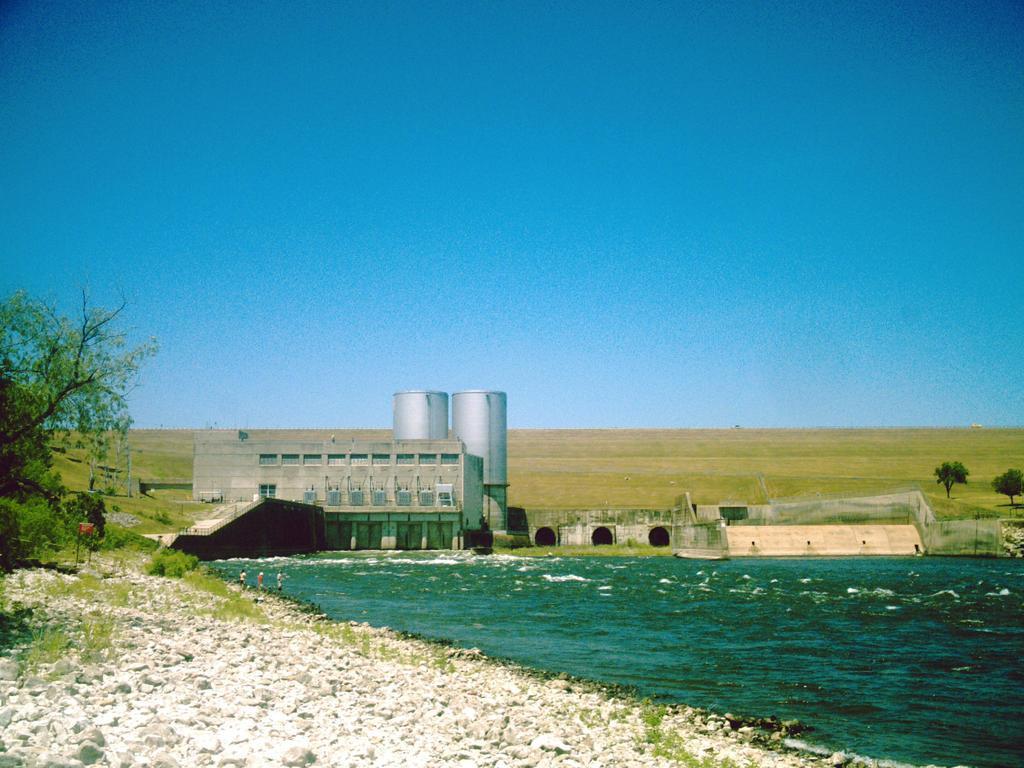Can you describe this image briefly? In this image I can see the sky and lake and some tankers visible in front of the lake and I can see tree visible on the left side. 